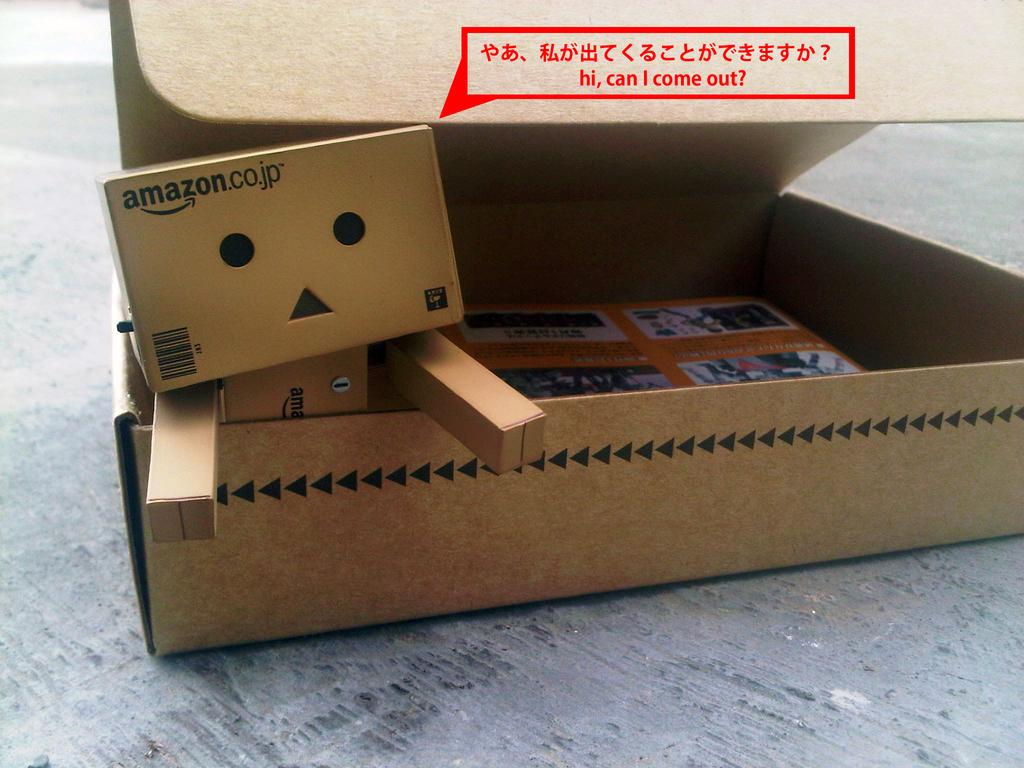<image>
Give a short and clear explanation of the subsequent image. the word come is on the brown box 